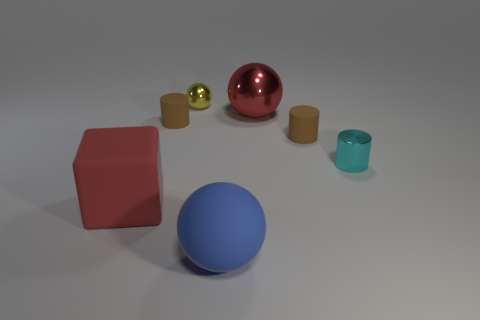Subtract all shiny cylinders. How many cylinders are left? 2 Subtract all gray balls. How many brown cylinders are left? 2 Subtract 1 cylinders. How many cylinders are left? 2 Add 2 yellow rubber cylinders. How many objects exist? 9 Subtract all cylinders. How many objects are left? 4 Subtract all gray cylinders. Subtract all red blocks. How many cylinders are left? 3 Subtract 0 gray blocks. How many objects are left? 7 Subtract all tiny yellow metallic balls. Subtract all big red balls. How many objects are left? 5 Add 2 cyan metal things. How many cyan metal things are left? 3 Add 4 large purple metallic things. How many large purple metallic things exist? 4 